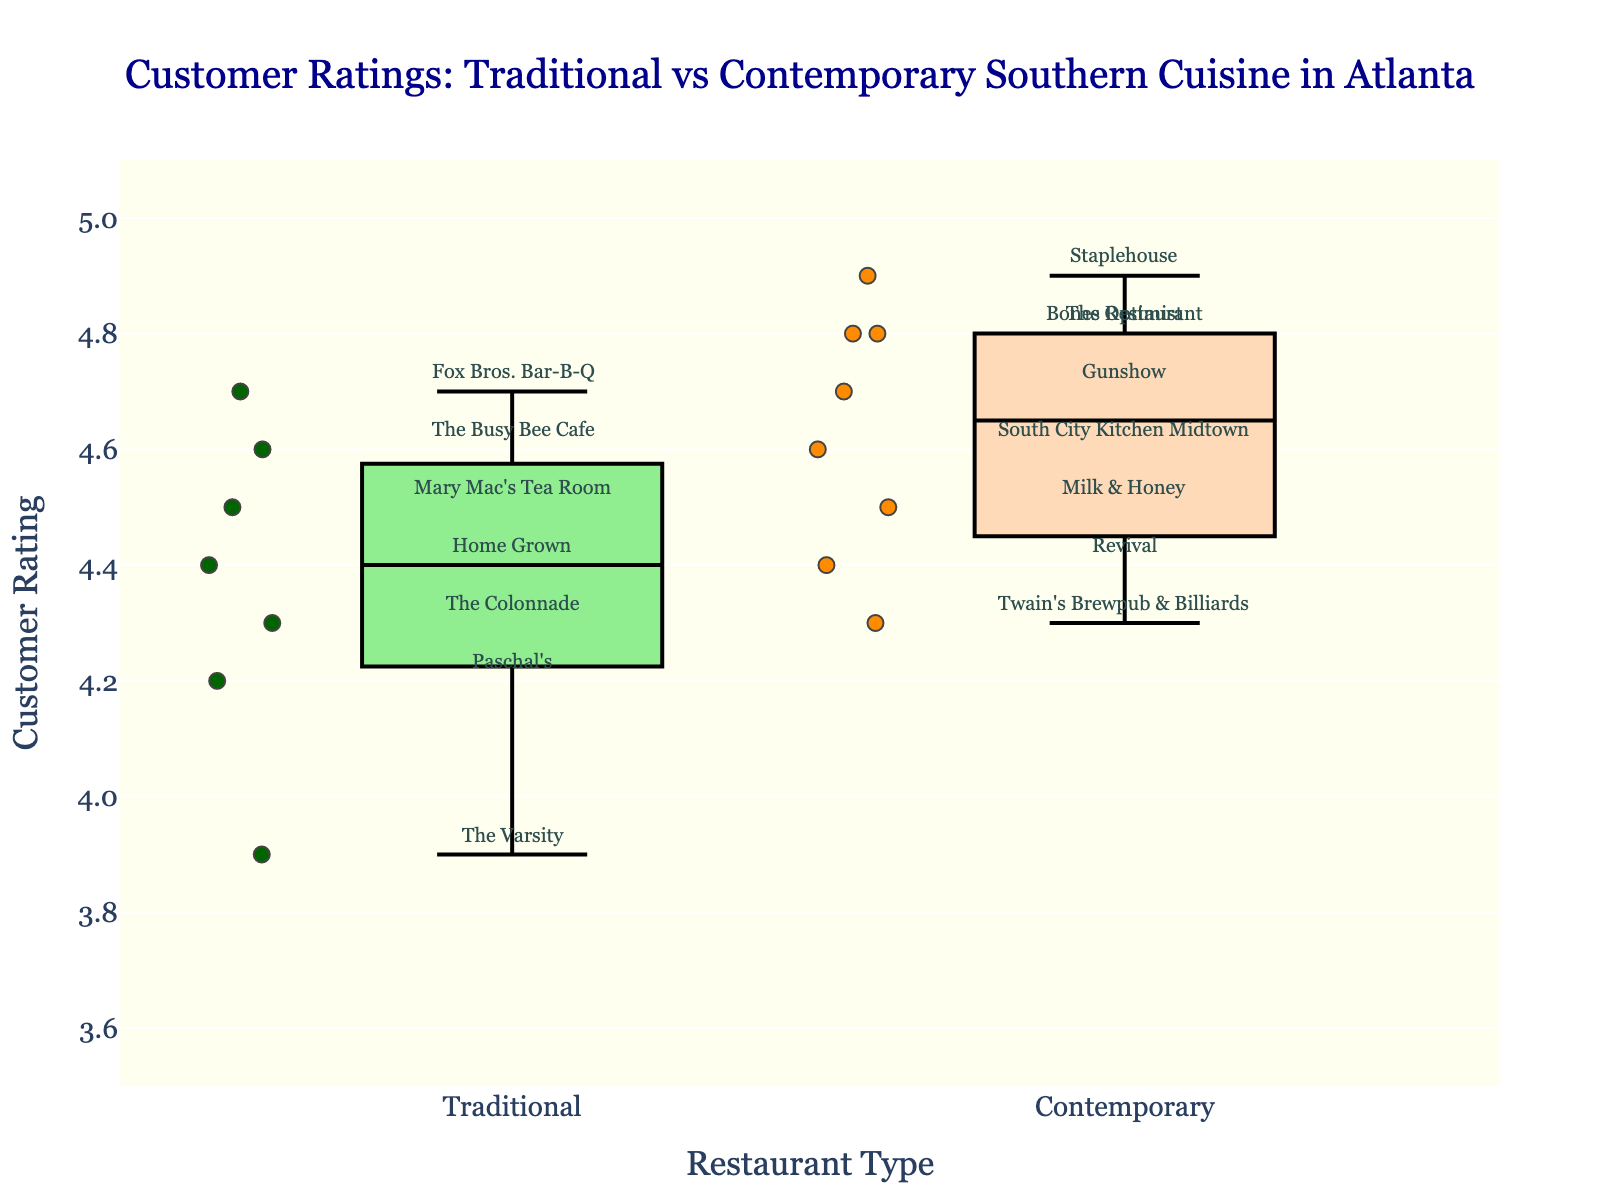What is the title of the plot? The title of the plot is located at the top, above the box plots. By reading this text, you can identify the title.
Answer: Customer Ratings: Traditional vs Contemporary Southern Cuisine in Atlanta How many traditional Southern restaurants are displayed in the plot? Count the number of points or annotations labeled under the "Traditional" category.
Answer: 7 What is the highest rating for contemporary Southern cuisine eateries? Look for the highest point or box end in the contemporary group and read the corresponding y-axis value.
Answer: 4.9 Which restaurant has the lowest rating, and what is its rating? Identify the lowest point on the y-axis and read the annotation near it to find the restaurant name.
Answer: The Varsity, 3.9 What is the average customer rating for traditional Southern restaurants? Sum all the individual ratings from the traditional group and divide by the number of restaurants. (4.3 + 4.5 + 4.2 + 4.6 + 3.9 + 4.4 + 4.7) / 7 = 30.6 / 7 = 4.37
Answer: 4.37 Which group has a higher median rating, and what is that median rating? Find the median value within each group by arranging the ratings in numerical order and identifying the middle value. For traditional, ratings are: 3.9, 4.2, 4.3, 4.4, 4.5, 4.6, 4.7. Median is 4.4. For contemporary, ratings are: 4.3, 4.4, 4.5, 4.6, 4.7, 4.8, 4.8, 4.9. Median is 4.7.
Answer: Contemporary, 4.7 Is there any overlapping in the ratings range between the two groups? Compare the highest and lowest points of the box plots for each group to see if they overlap. Traditional: 3.9 to 4.7, Contemporary: 4.3 to 4.9.
Answer: Yes Which restaurant has the highest rating, and what type of cuisine does it serve? Identify the highest point on the y-axis and read the corresponding annotation for the restaurant name and its type.
Answer: Staplehouse, Contemporary How do the interquartile ranges (IQR) of the traditional and contemporary groups compare? The IQR is the range between the first quartile (25th percentile) and the third quartile (75th percentile) of the box plot. Measure these ranges from the box plots.
Answer: Contemporary has a narrower IQR than Traditional 